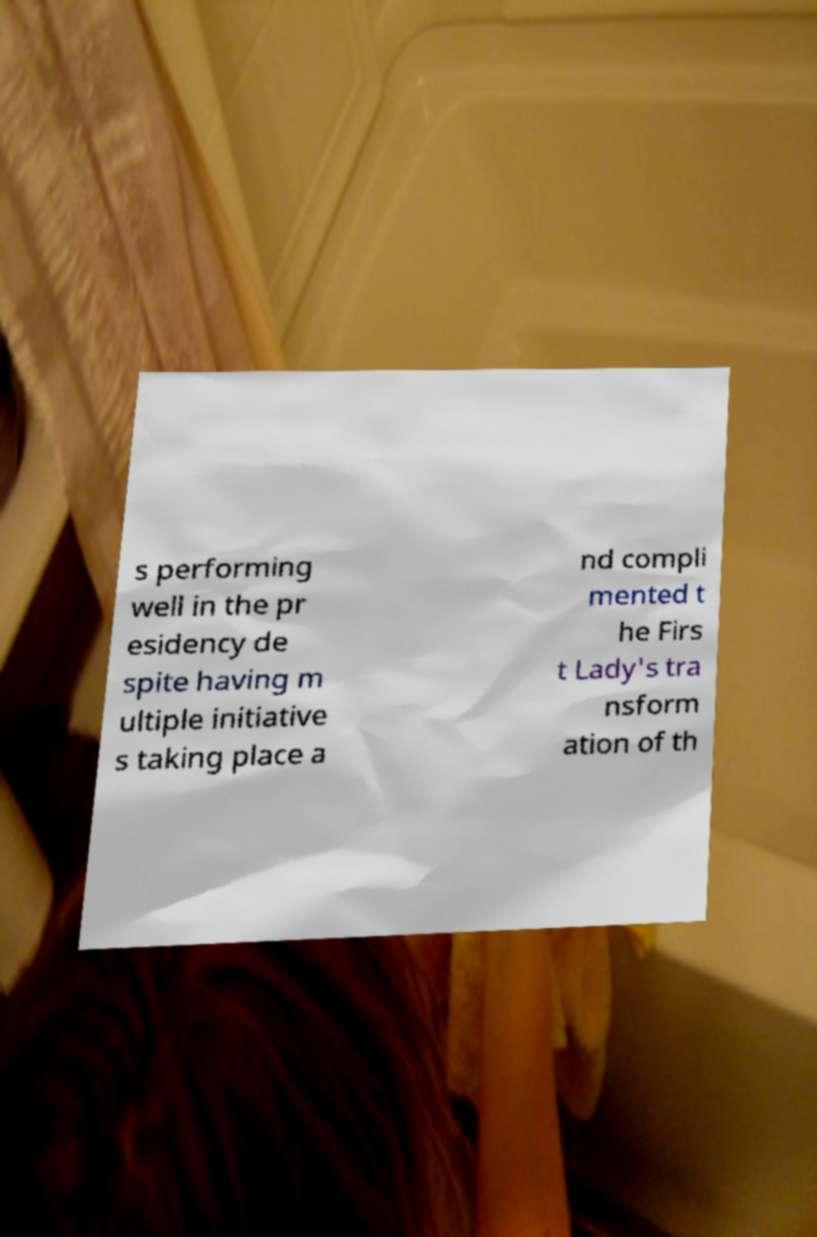Please read and relay the text visible in this image. What does it say? s performing well in the pr esidency de spite having m ultiple initiative s taking place a nd compli mented t he Firs t Lady's tra nsform ation of th 